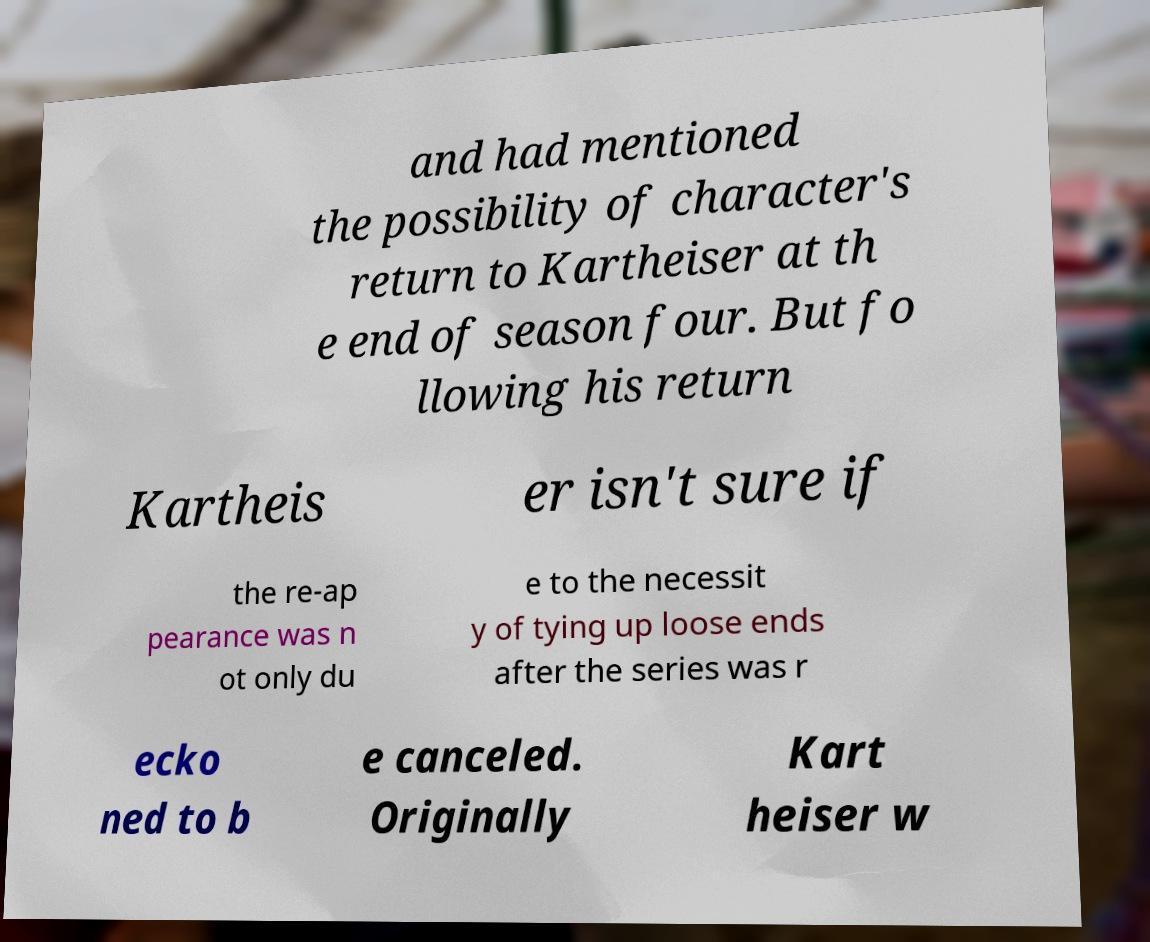Can you read and provide the text displayed in the image?This photo seems to have some interesting text. Can you extract and type it out for me? and had mentioned the possibility of character's return to Kartheiser at th e end of season four. But fo llowing his return Kartheis er isn't sure if the re-ap pearance was n ot only du e to the necessit y of tying up loose ends after the series was r ecko ned to b e canceled. Originally Kart heiser w 